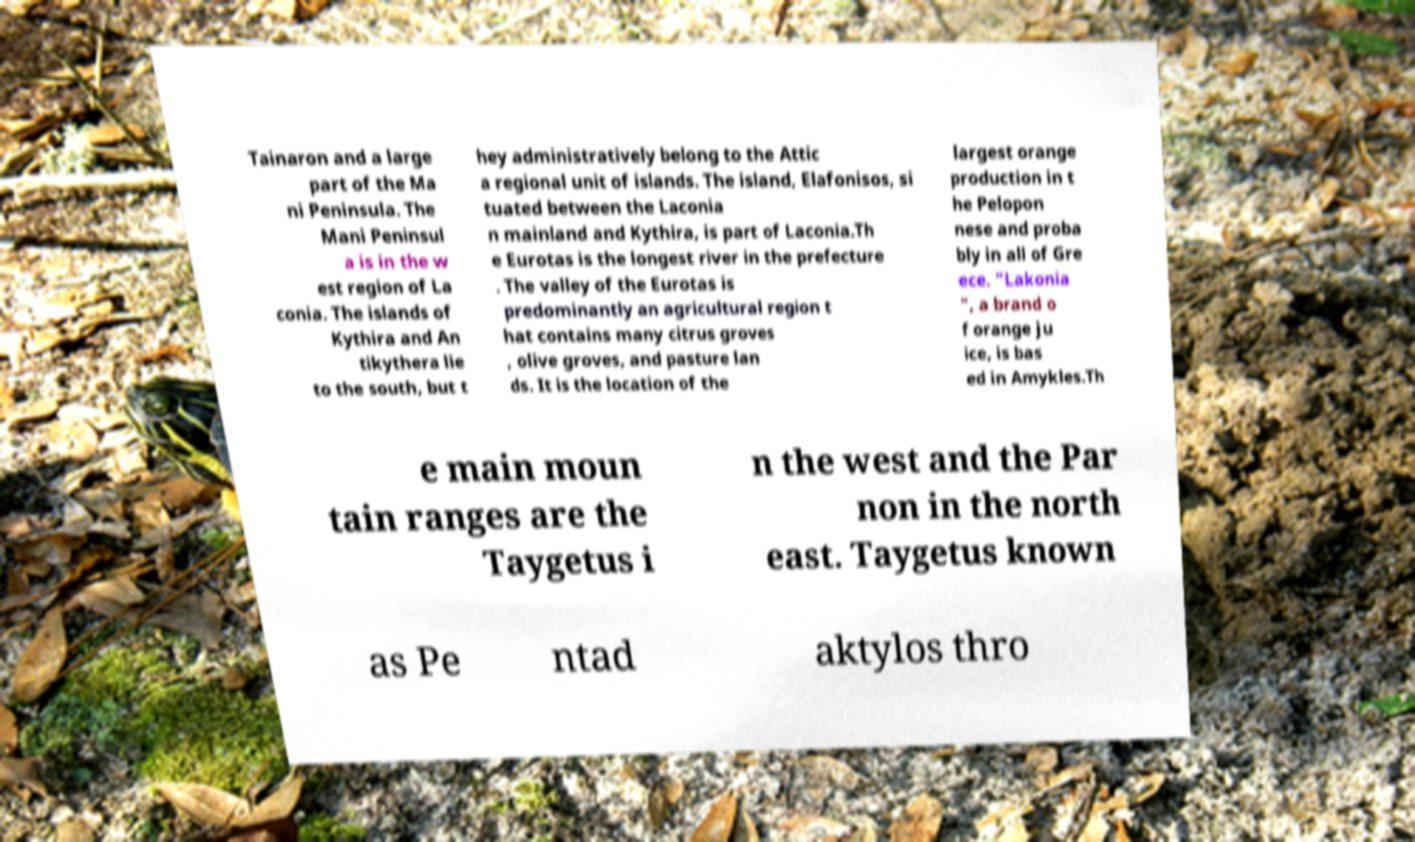Please identify and transcribe the text found in this image. Tainaron and a large part of the Ma ni Peninsula. The Mani Peninsul a is in the w est region of La conia. The islands of Kythira and An tikythera lie to the south, but t hey administratively belong to the Attic a regional unit of islands. The island, Elafonisos, si tuated between the Laconia n mainland and Kythira, is part of Laconia.Th e Eurotas is the longest river in the prefecture . The valley of the Eurotas is predominantly an agricultural region t hat contains many citrus groves , olive groves, and pasture lan ds. It is the location of the largest orange production in t he Pelopon nese and proba bly in all of Gre ece. "Lakonia ", a brand o f orange ju ice, is bas ed in Amykles.Th e main moun tain ranges are the Taygetus i n the west and the Par non in the north east. Taygetus known as Pe ntad aktylos thro 